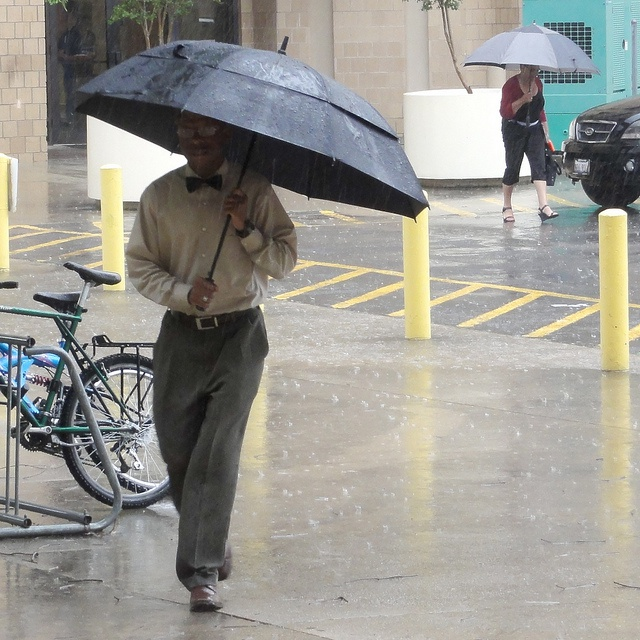Describe the objects in this image and their specific colors. I can see people in lightgray, black, and gray tones, umbrella in lightgray, black, darkgray, and gray tones, bicycle in lightgray, darkgray, black, and gray tones, car in lightgray, black, gray, and darkgray tones, and people in lightgray, gray, black, and darkgray tones in this image. 